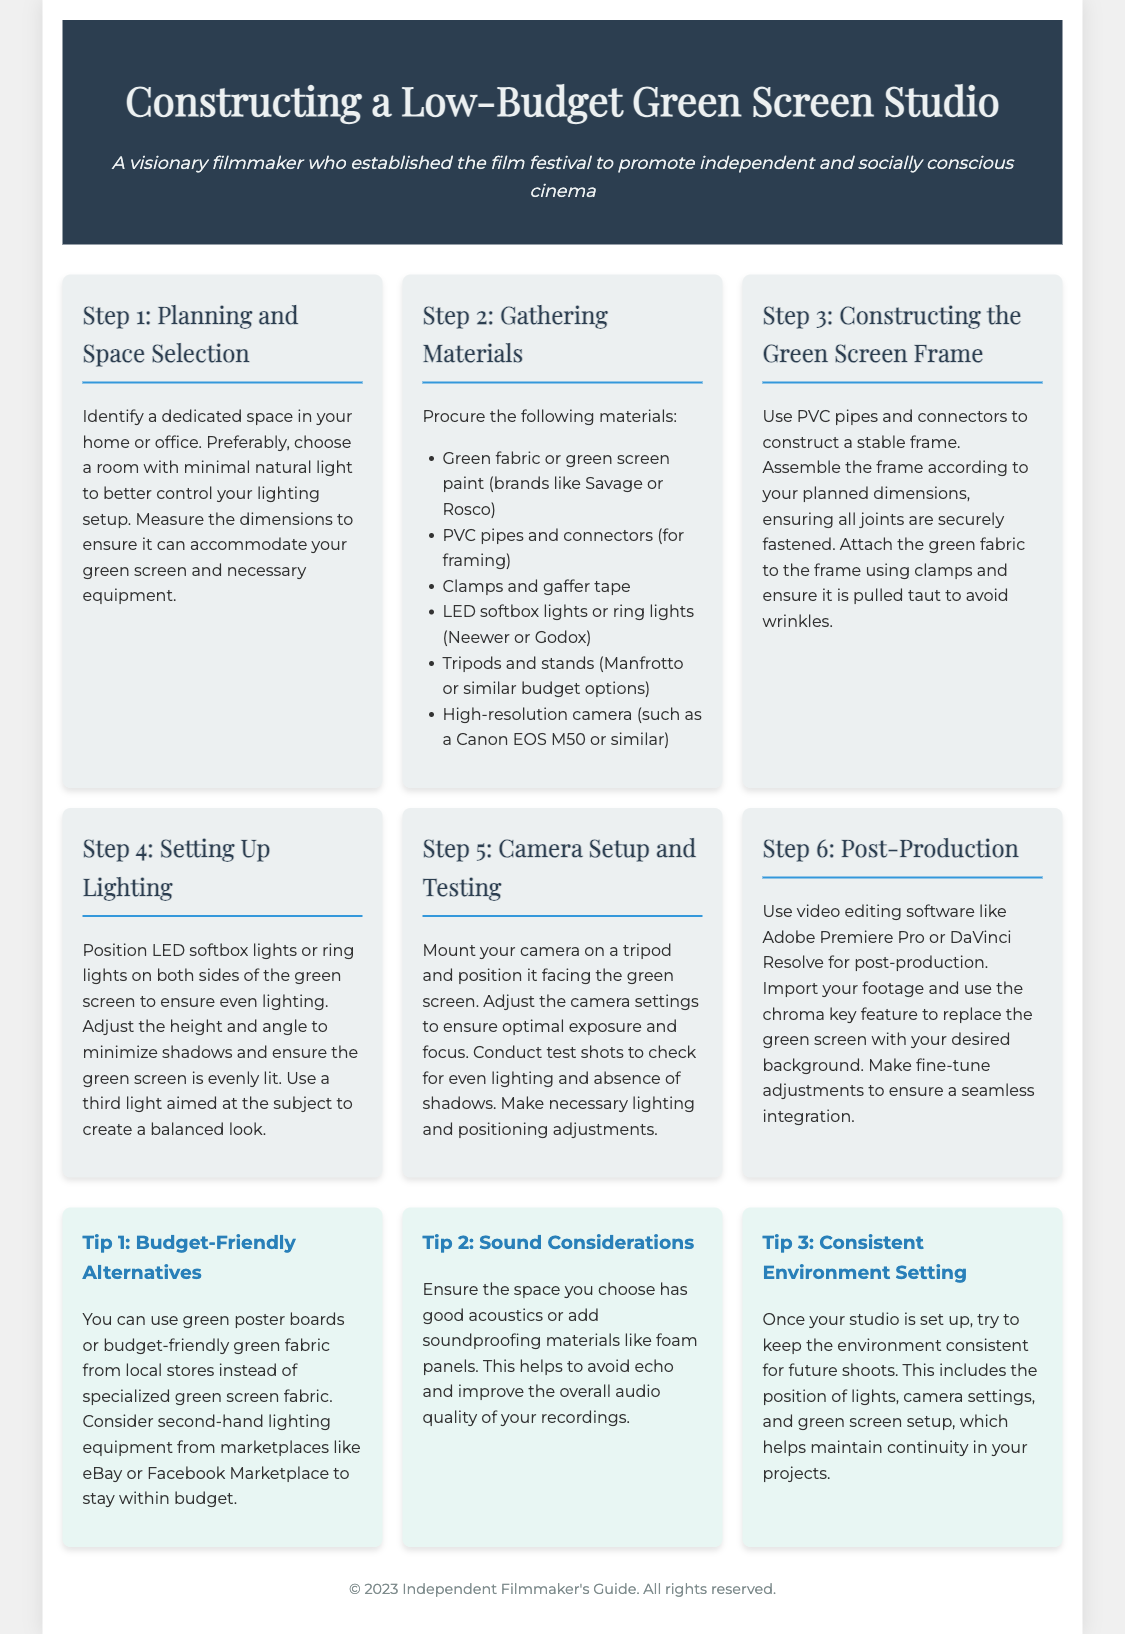What is the first step in constructing a green screen studio? The first step involves identifying a dedicated space in your home or office with minimal natural light.
Answer: Planning and Space Selection What materials are suggested for gathering? The document lists specific materials needed for constructing a green screen studio.
Answer: Green fabric or green screen paint, PVC pipes and connectors, clamps and gaffer tape, LED softbox lights or ring lights, tripods and stands, high-resolution camera How should the green screen frame be constructed? It involves using PVC pipes and connectors to create a stable frame while ensuring all joints are securely fastened.
Answer: Use PVC pipes and connectors to construct a stable frame What is the purpose of the third light in the lighting setup? The third light is used to create a balanced look focused on the subject.
Answer: To create a balanced look Which video editing software is recommended for post-production? The document specifies video editing software that is commonly used for editing green screen footage.
Answer: Adobe Premiere Pro or DaVinci Resolve What is a budget-friendly alternative for the green screen? Alternatives are suggested for those who want to minimize costs.
Answer: Green poster boards or budget-friendly green fabric How can one ensure the audio quality during recordings? The document provides advice about setting up the shooting environment to prevent audio issues.
Answer: By adding soundproofing materials like foam panels What should be maintained for future shoots? This involves keeping consistent settings after the initial setup.
Answer: Environment consistent 